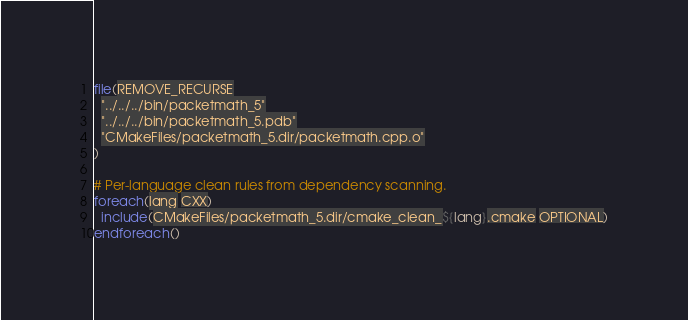Convert code to text. <code><loc_0><loc_0><loc_500><loc_500><_CMake_>file(REMOVE_RECURSE
  "../../../bin/packetmath_5"
  "../../../bin/packetmath_5.pdb"
  "CMakeFiles/packetmath_5.dir/packetmath.cpp.o"
)

# Per-language clean rules from dependency scanning.
foreach(lang CXX)
  include(CMakeFiles/packetmath_5.dir/cmake_clean_${lang}.cmake OPTIONAL)
endforeach()
</code> 